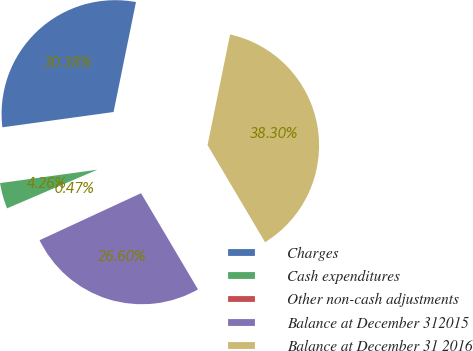Convert chart to OTSL. <chart><loc_0><loc_0><loc_500><loc_500><pie_chart><fcel>Charges<fcel>Cash expenditures<fcel>Other non-cash adjustments<fcel>Balance at December 312015<fcel>Balance at December 31 2016<nl><fcel>30.38%<fcel>4.26%<fcel>0.47%<fcel>26.6%<fcel>38.3%<nl></chart> 